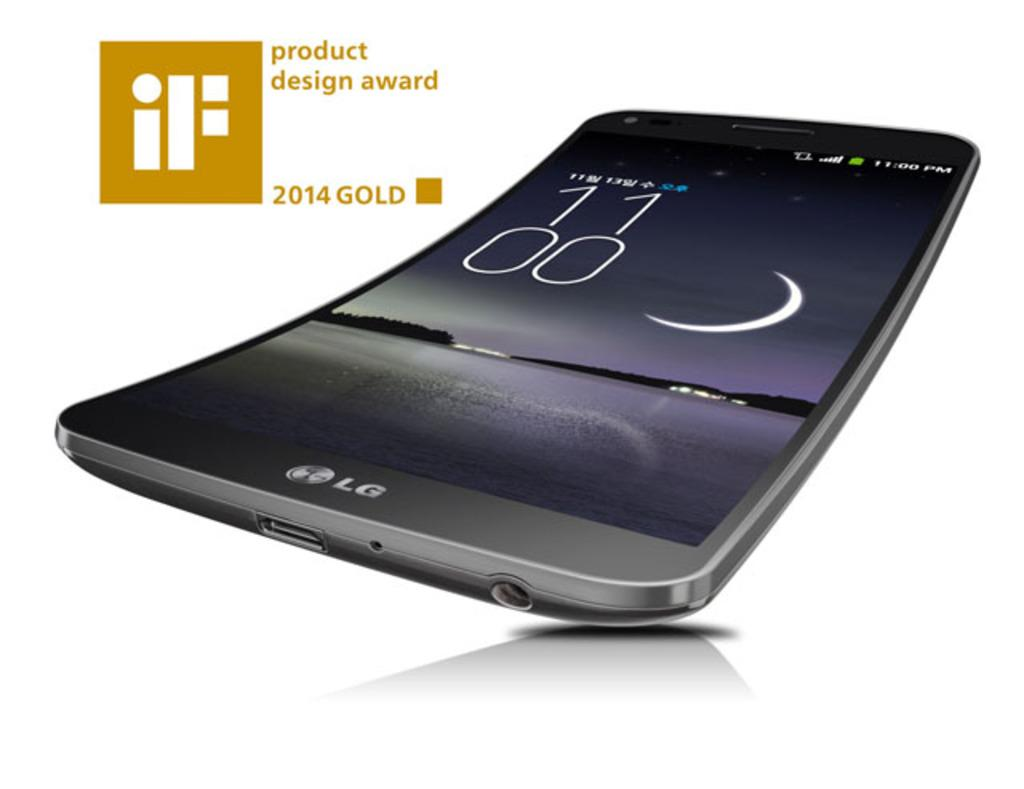<image>
Render a clear and concise summary of the photo. the screen of a bendable lg phone that won the product design award. 